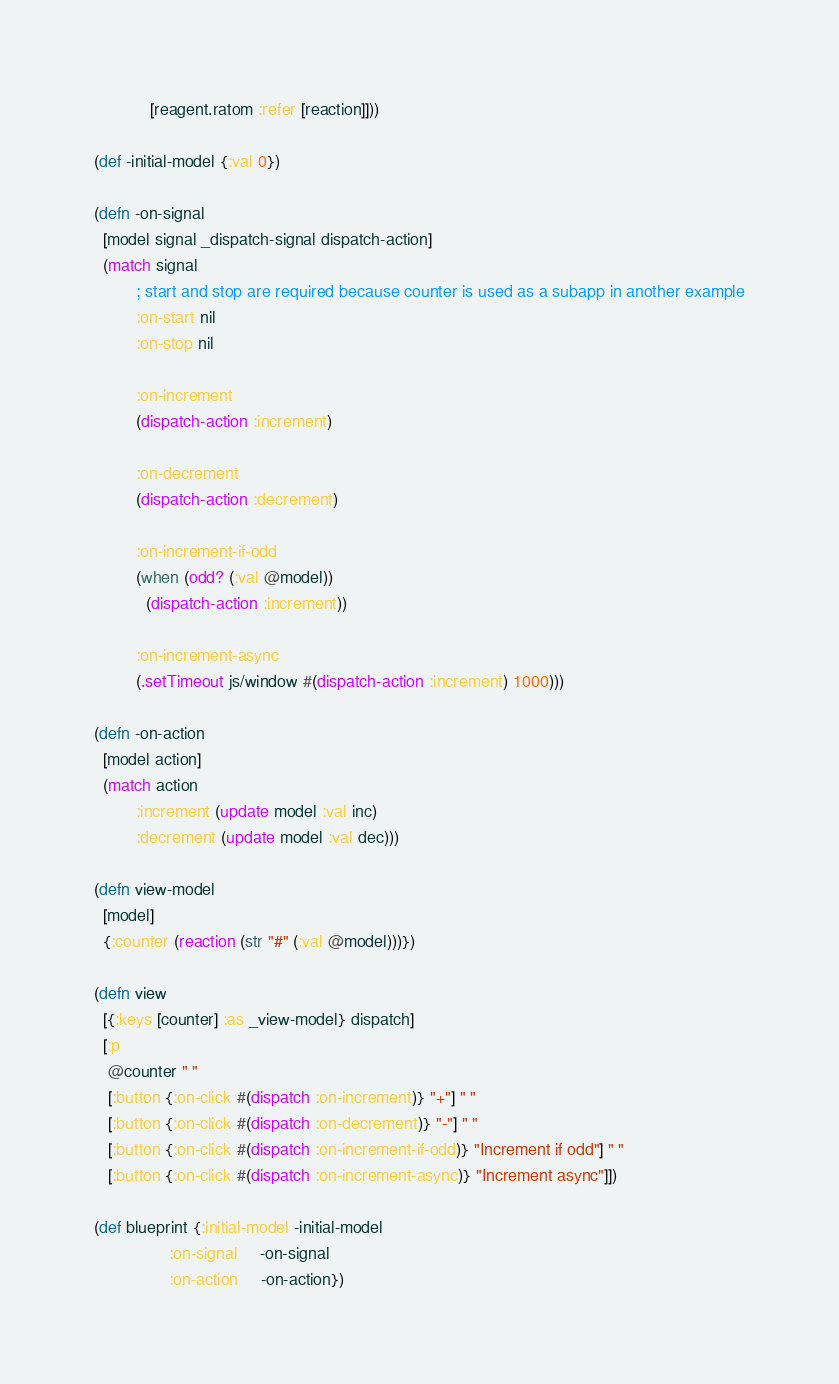Convert code to text. <code><loc_0><loc_0><loc_500><loc_500><_Clojure_>            [reagent.ratom :refer [reaction]]))

(def -initial-model {:val 0})

(defn -on-signal
  [model signal _dispatch-signal dispatch-action]
  (match signal
         ; start and stop are required because counter is used as a subapp in another example
         :on-start nil
         :on-stop nil

         :on-increment
         (dispatch-action :increment)

         :on-decrement
         (dispatch-action :decrement)

         :on-increment-if-odd
         (when (odd? (:val @model))
           (dispatch-action :increment))

         :on-increment-async
         (.setTimeout js/window #(dispatch-action :increment) 1000)))

(defn -on-action
  [model action]
  (match action
         :increment (update model :val inc)
         :decrement (update model :val dec)))

(defn view-model
  [model]
  {:counter (reaction (str "#" (:val @model)))})

(defn view
  [{:keys [counter] :as _view-model} dispatch]
  [:p
   @counter " "
   [:button {:on-click #(dispatch :on-increment)} "+"] " "
   [:button {:on-click #(dispatch :on-decrement)} "-"] " "
   [:button {:on-click #(dispatch :on-increment-if-odd)} "Increment if odd"] " "
   [:button {:on-click #(dispatch :on-increment-async)} "Increment async"]])

(def blueprint {:initial-model -initial-model
                :on-signal     -on-signal
                :on-action     -on-action})
</code> 